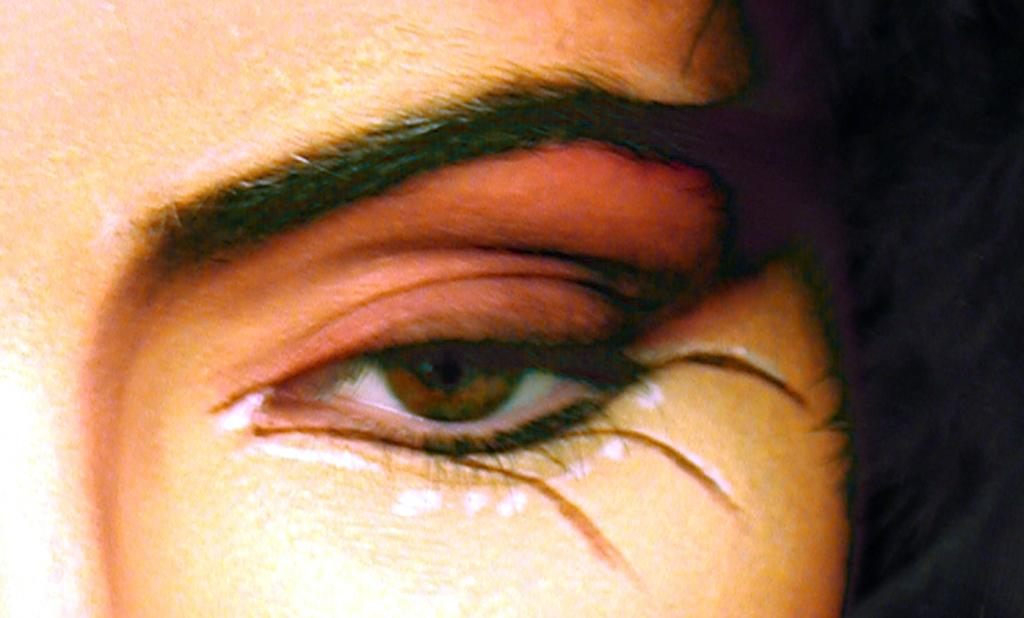What is depicted in the image? There is a part of a face in the image. What specific facial feature can be seen in the image? The face has an eye. Are there any other facial features visible in the image? Yes, the face has eyebrows. What type of support can be seen in the wilderness in the image? There is no support or wilderness present in the image; it only features a part of a face with an eye and eyebrows. 